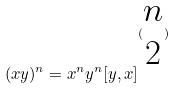Convert formula to latex. <formula><loc_0><loc_0><loc_500><loc_500>( x y ) ^ { n } = x ^ { n } y ^ { n } [ y , x ] ^ { ( \begin{matrix} n \\ 2 \end{matrix} ) }</formula> 